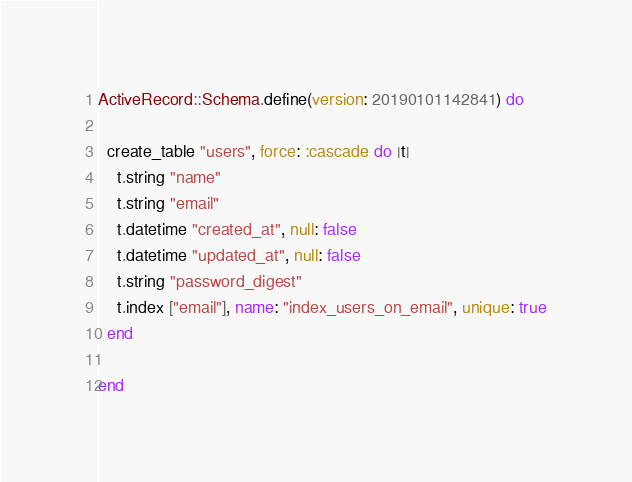Convert code to text. <code><loc_0><loc_0><loc_500><loc_500><_Ruby_>
ActiveRecord::Schema.define(version: 20190101142841) do

  create_table "users", force: :cascade do |t|
    t.string "name"
    t.string "email"
    t.datetime "created_at", null: false
    t.datetime "updated_at", null: false
    t.string "password_digest"
    t.index ["email"], name: "index_users_on_email", unique: true
  end

end
</code> 